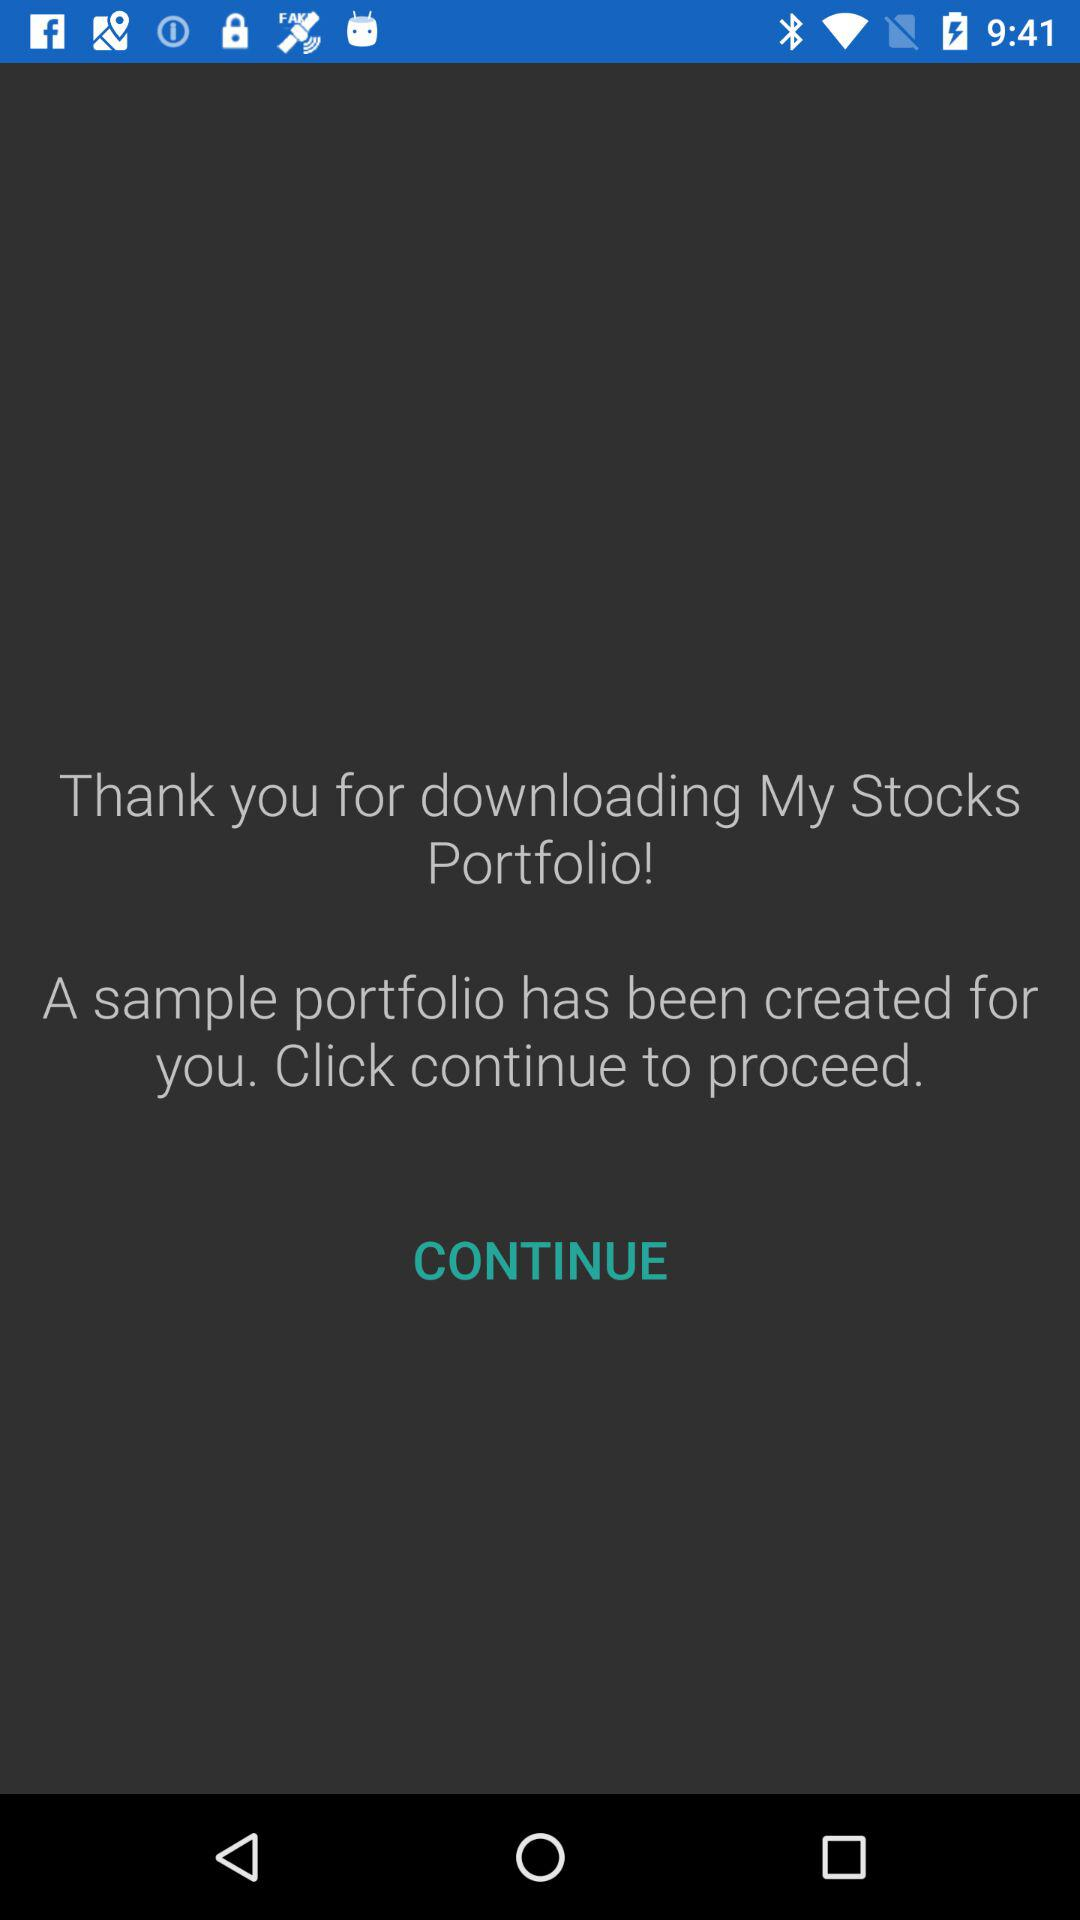What is the application name? The application name is "My Stocks Portfolio". 